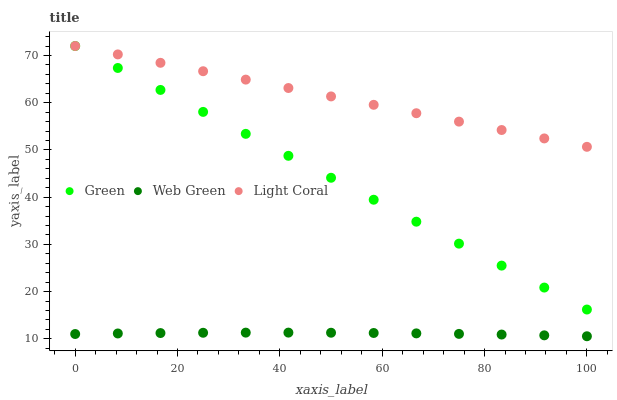Does Web Green have the minimum area under the curve?
Answer yes or no. Yes. Does Light Coral have the maximum area under the curve?
Answer yes or no. Yes. Does Green have the minimum area under the curve?
Answer yes or no. No. Does Green have the maximum area under the curve?
Answer yes or no. No. Is Light Coral the smoothest?
Answer yes or no. Yes. Is Web Green the roughest?
Answer yes or no. Yes. Is Green the smoothest?
Answer yes or no. No. Is Green the roughest?
Answer yes or no. No. Does Web Green have the lowest value?
Answer yes or no. Yes. Does Green have the lowest value?
Answer yes or no. No. Does Green have the highest value?
Answer yes or no. Yes. Does Web Green have the highest value?
Answer yes or no. No. Is Web Green less than Green?
Answer yes or no. Yes. Is Green greater than Web Green?
Answer yes or no. Yes. Does Light Coral intersect Green?
Answer yes or no. Yes. Is Light Coral less than Green?
Answer yes or no. No. Is Light Coral greater than Green?
Answer yes or no. No. Does Web Green intersect Green?
Answer yes or no. No. 